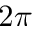<formula> <loc_0><loc_0><loc_500><loc_500>2 \pi</formula> 